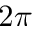<formula> <loc_0><loc_0><loc_500><loc_500>2 \pi</formula> 